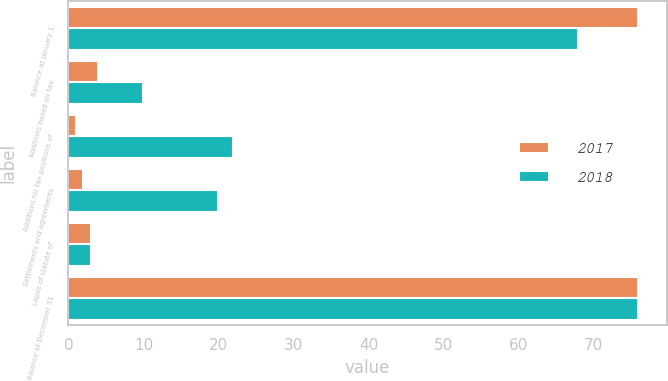<chart> <loc_0><loc_0><loc_500><loc_500><stacked_bar_chart><ecel><fcel>Balance at January 1<fcel>Additions based on tax<fcel>Additions for tax positions of<fcel>Settlements and agreements<fcel>Lapse of statute of<fcel>Balance at December 31<nl><fcel>2017<fcel>76<fcel>4<fcel>1<fcel>2<fcel>3<fcel>76<nl><fcel>2018<fcel>68<fcel>10<fcel>22<fcel>20<fcel>3<fcel>76<nl></chart> 